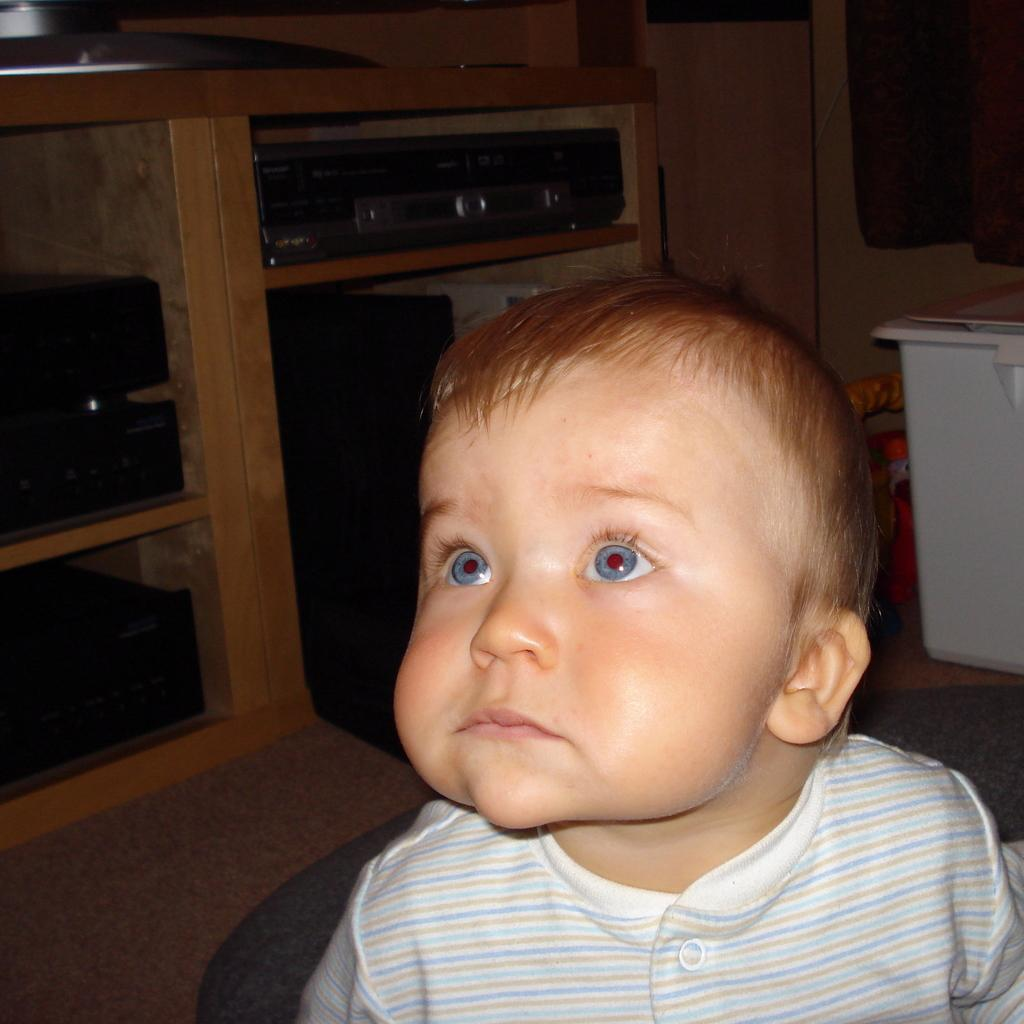What is the main subject in the foreground of the image? There is a small baby in the foreground of the image. What can be seen in the background of the image? There is a rack in the background of the image. Are there any other objects visible in the background? Yes, there are other objects present in the background of the image. What type of tub is visible in the image? There is no tub present in the image. How does the baby establish its territory in the image? The baby does not establish any territory in the image; it is simply a small baby in the foreground. 